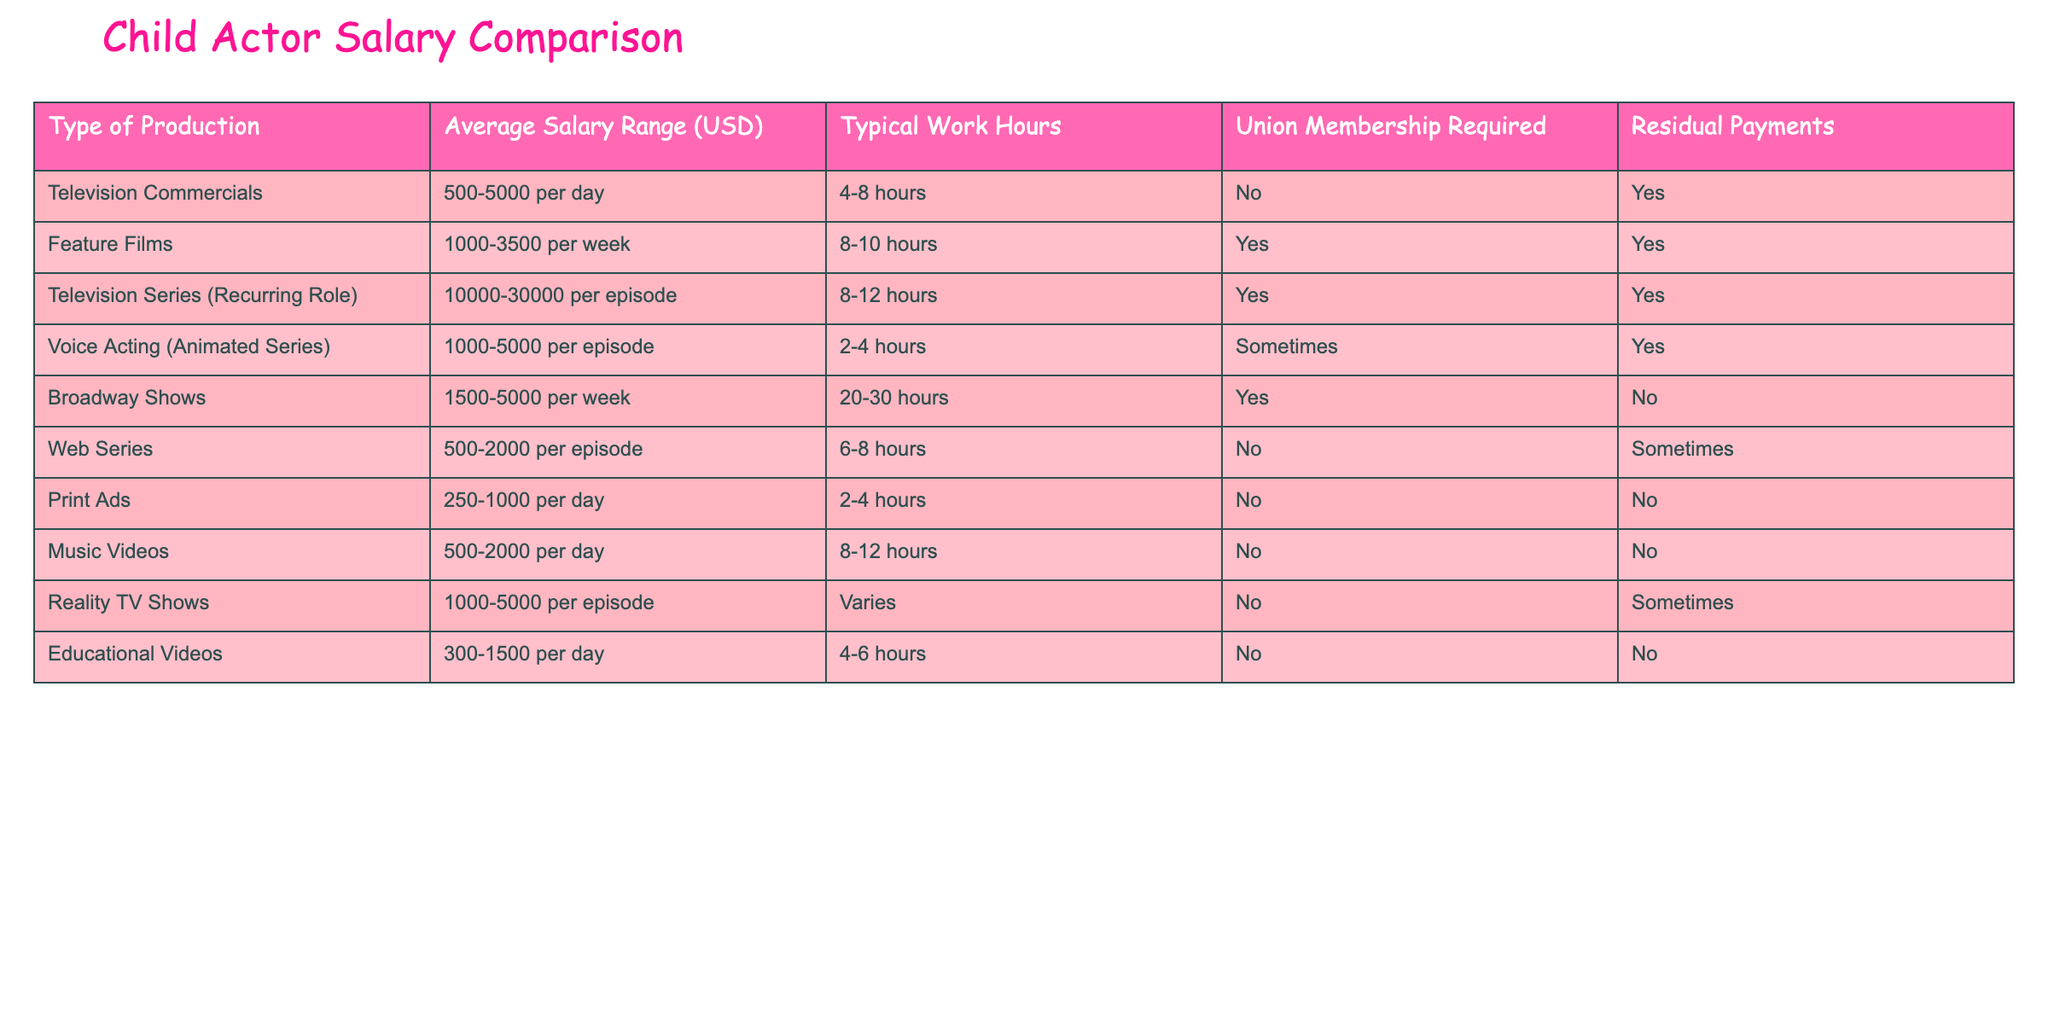What is the average salary range for Television Commercials? The table shows that the average salary range for Television Commercials is from 500 to 5000 per day.
Answer: 500-5000 per day Is union membership required for Voice Acting in Animated Series? According to the table, Voice Acting in Animated Series indicates that union membership is sometimes required.
Answer: Sometimes Which type of production has the highest typical salary per episode? Looking at the table, Television Series (Recurring Role) has an average salary range of 10000 to 30000 per episode, which is higher than all other productions listed.
Answer: Television Series (Recurring Role) What is the difference in average salary range between Feature Films and Broadway Shows? The average salary range for Feature Films is 1000 to 3500 per week, while for Broadway Shows it is 1500 to 5000 per week. The difference is calculated by taking the lower and upper ends of both ranges: 1500 - 1000 = 500 (lower) and 5000 - 3500 = 1500 (upper), so the overall difference between ranges could be seen as 500 to 1500.
Answer: 500-1500 Do Reality TV Shows offer residual payments? According to the table, Reality TV Shows have a column that states "Residual Payments" as sometimes, meaning they do not consistently offer them.
Answer: Sometimes What is the typical work hour difference between Print Ads and Television Commercials? Print Ads typically require 2-4 hours, while Television Commercials require 4-8 hours. The difference in work hours could be seen as a range of 0 to 6 hours, specifically, it ranges from 2-4 hours for Print Ads and 4-8 hours for Television Commercials.
Answer: 0-6 hours Which types of productions do not require union membership? By reviewing the table, we can see that Television Commercials, Web Series, Music Videos, and Educational Videos do not require union membership at all.
Answer: Television Commercials, Web Series, Music Videos, Educational Videos What is the average number of typical work hours for Broadway Shows compared to Television Series? Broadway Shows have a typical work hour range of 20-30 hours per week, while Television Series have a range of 8-12 hours per episode. Converting Broadway Shows' hours to a per-episode basis (assuming 1 episode = 1 week) averages to 25 hours. Comparing: 25 (Broadway) vs 10 (Television Series), there is a significant difference of 15 hours.
Answer: 15 hours difference How many types of productions offer no residual payments? By counting the rows in the table, we see that Print Ads and Broadway Shows do not offer residual payments, which sums up to 2 types of productions.
Answer: 2 types of productions 